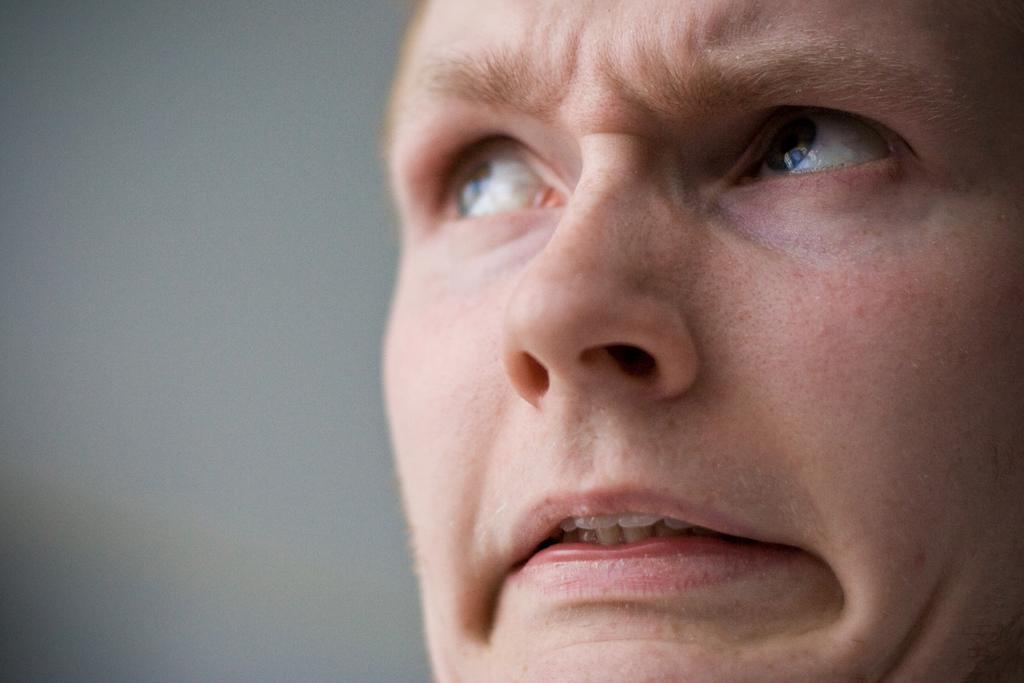Please provide a concise description of this image. In this image in the middle, there is a man, he is staring at something. In the background there is wall. 